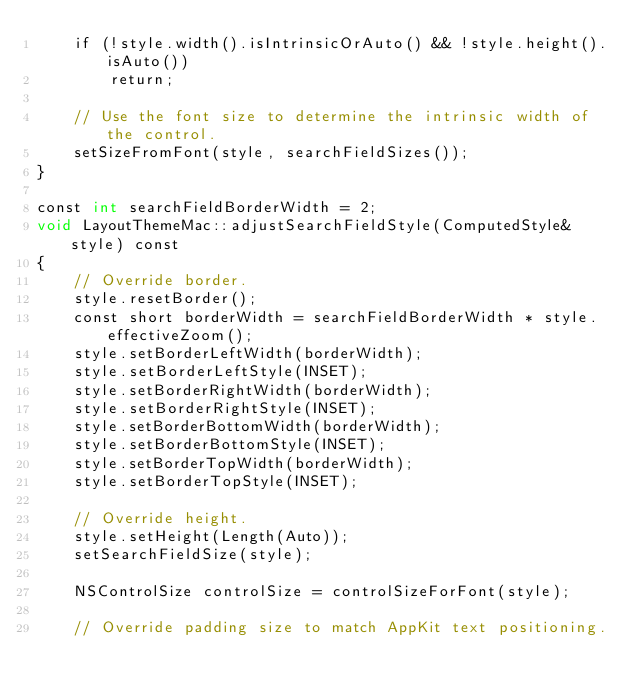Convert code to text. <code><loc_0><loc_0><loc_500><loc_500><_ObjectiveC_>    if (!style.width().isIntrinsicOrAuto() && !style.height().isAuto())
        return;

    // Use the font size to determine the intrinsic width of the control.
    setSizeFromFont(style, searchFieldSizes());
}

const int searchFieldBorderWidth = 2;
void LayoutThemeMac::adjustSearchFieldStyle(ComputedStyle& style) const
{
    // Override border.
    style.resetBorder();
    const short borderWidth = searchFieldBorderWidth * style.effectiveZoom();
    style.setBorderLeftWidth(borderWidth);
    style.setBorderLeftStyle(INSET);
    style.setBorderRightWidth(borderWidth);
    style.setBorderRightStyle(INSET);
    style.setBorderBottomWidth(borderWidth);
    style.setBorderBottomStyle(INSET);
    style.setBorderTopWidth(borderWidth);
    style.setBorderTopStyle(INSET);

    // Override height.
    style.setHeight(Length(Auto));
    setSearchFieldSize(style);

    NSControlSize controlSize = controlSizeForFont(style);

    // Override padding size to match AppKit text positioning.</code> 